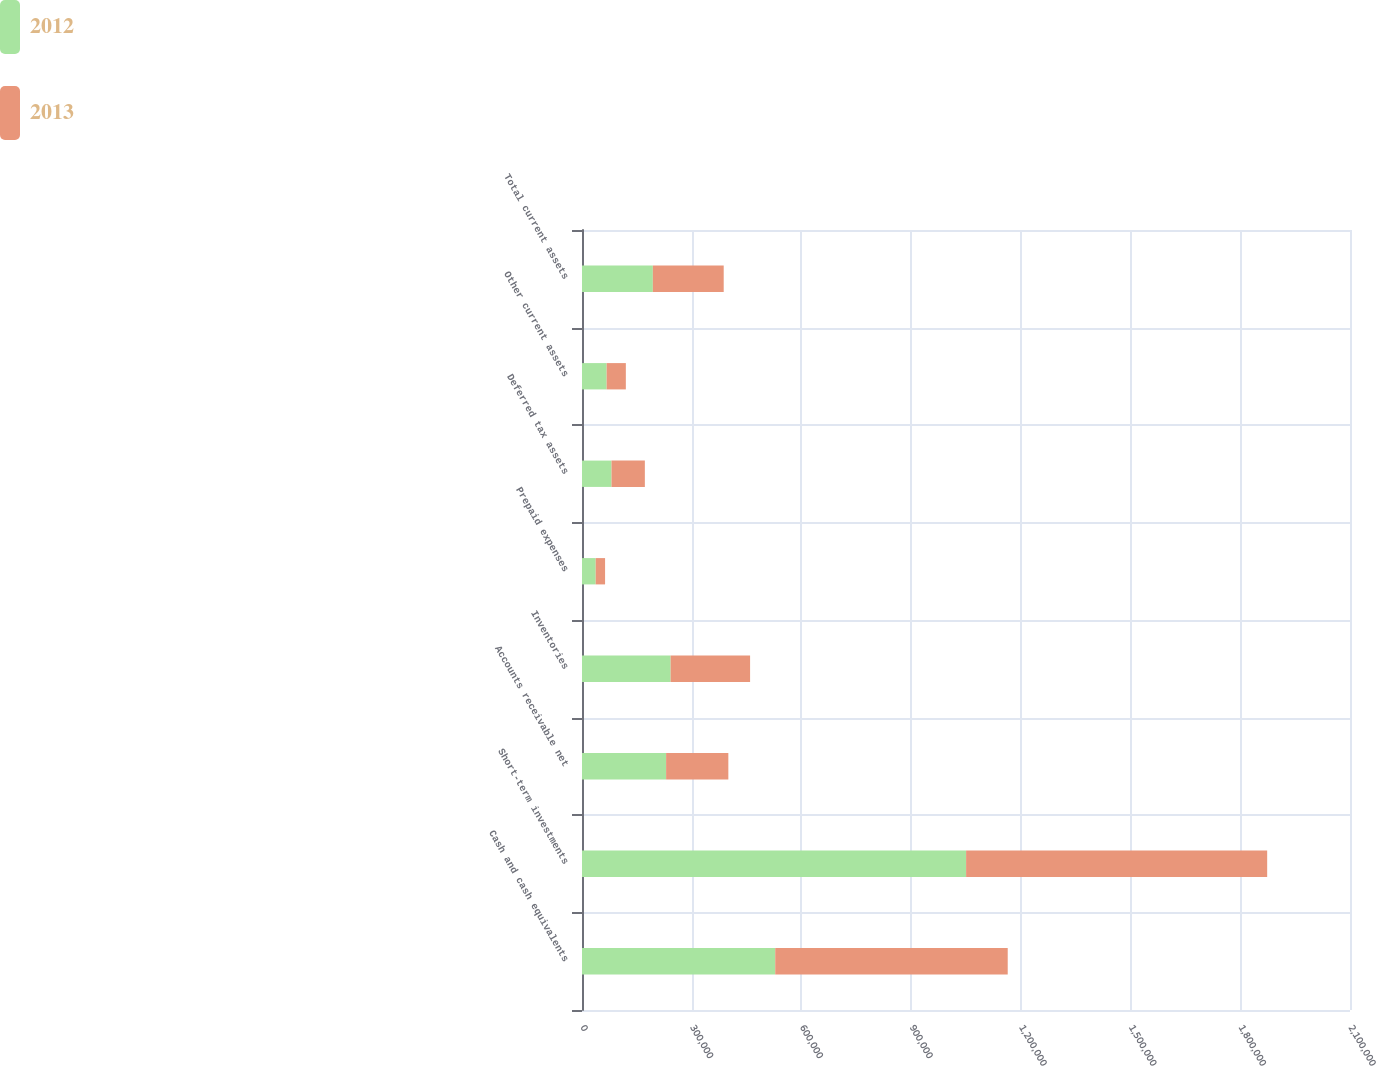Convert chart to OTSL. <chart><loc_0><loc_0><loc_500><loc_500><stacked_bar_chart><ecel><fcel>Cash and cash equivalents<fcel>Short-term investments<fcel>Accounts receivable net<fcel>Inventories<fcel>Prepaid expenses<fcel>Deferred tax assets<fcel>Other current assets<fcel>Total current assets<nl><fcel>2012<fcel>528334<fcel>1.05026e+06<fcel>229955<fcel>242334<fcel>37439<fcel>80687<fcel>67358<fcel>193740<nl><fcel>2013<fcel>635755<fcel>823254<fcel>170201<fcel>217278<fcel>25658<fcel>91191<fcel>52524<fcel>193740<nl></chart> 